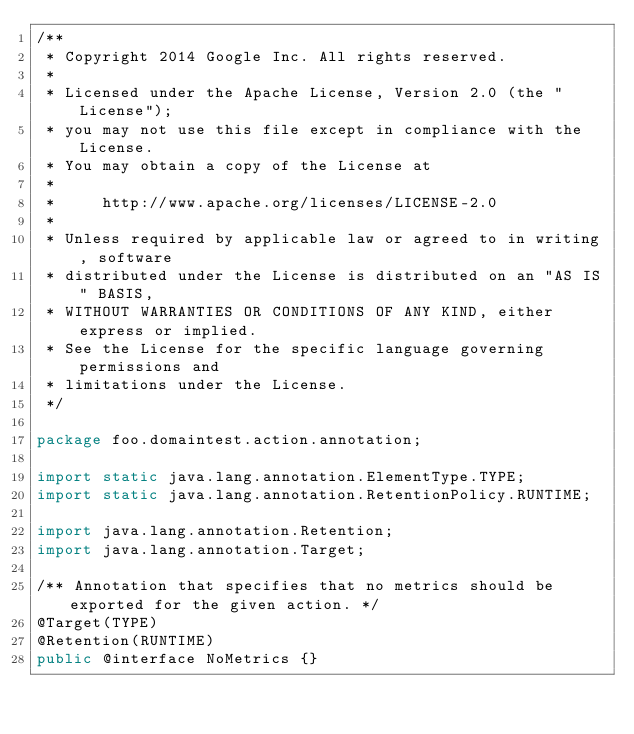Convert code to text. <code><loc_0><loc_0><loc_500><loc_500><_Java_>/**
 * Copyright 2014 Google Inc. All rights reserved.
 *
 * Licensed under the Apache License, Version 2.0 (the "License");
 * you may not use this file except in compliance with the License.
 * You may obtain a copy of the License at
 *
 *     http://www.apache.org/licenses/LICENSE-2.0
 *
 * Unless required by applicable law or agreed to in writing, software
 * distributed under the License is distributed on an "AS IS" BASIS,
 * WITHOUT WARRANTIES OR CONDITIONS OF ANY KIND, either express or implied.
 * See the License for the specific language governing permissions and
 * limitations under the License.
 */

package foo.domaintest.action.annotation;

import static java.lang.annotation.ElementType.TYPE;
import static java.lang.annotation.RetentionPolicy.RUNTIME;

import java.lang.annotation.Retention;
import java.lang.annotation.Target;

/** Annotation that specifies that no metrics should be exported for the given action. */
@Target(TYPE)
@Retention(RUNTIME)
public @interface NoMetrics {}
</code> 